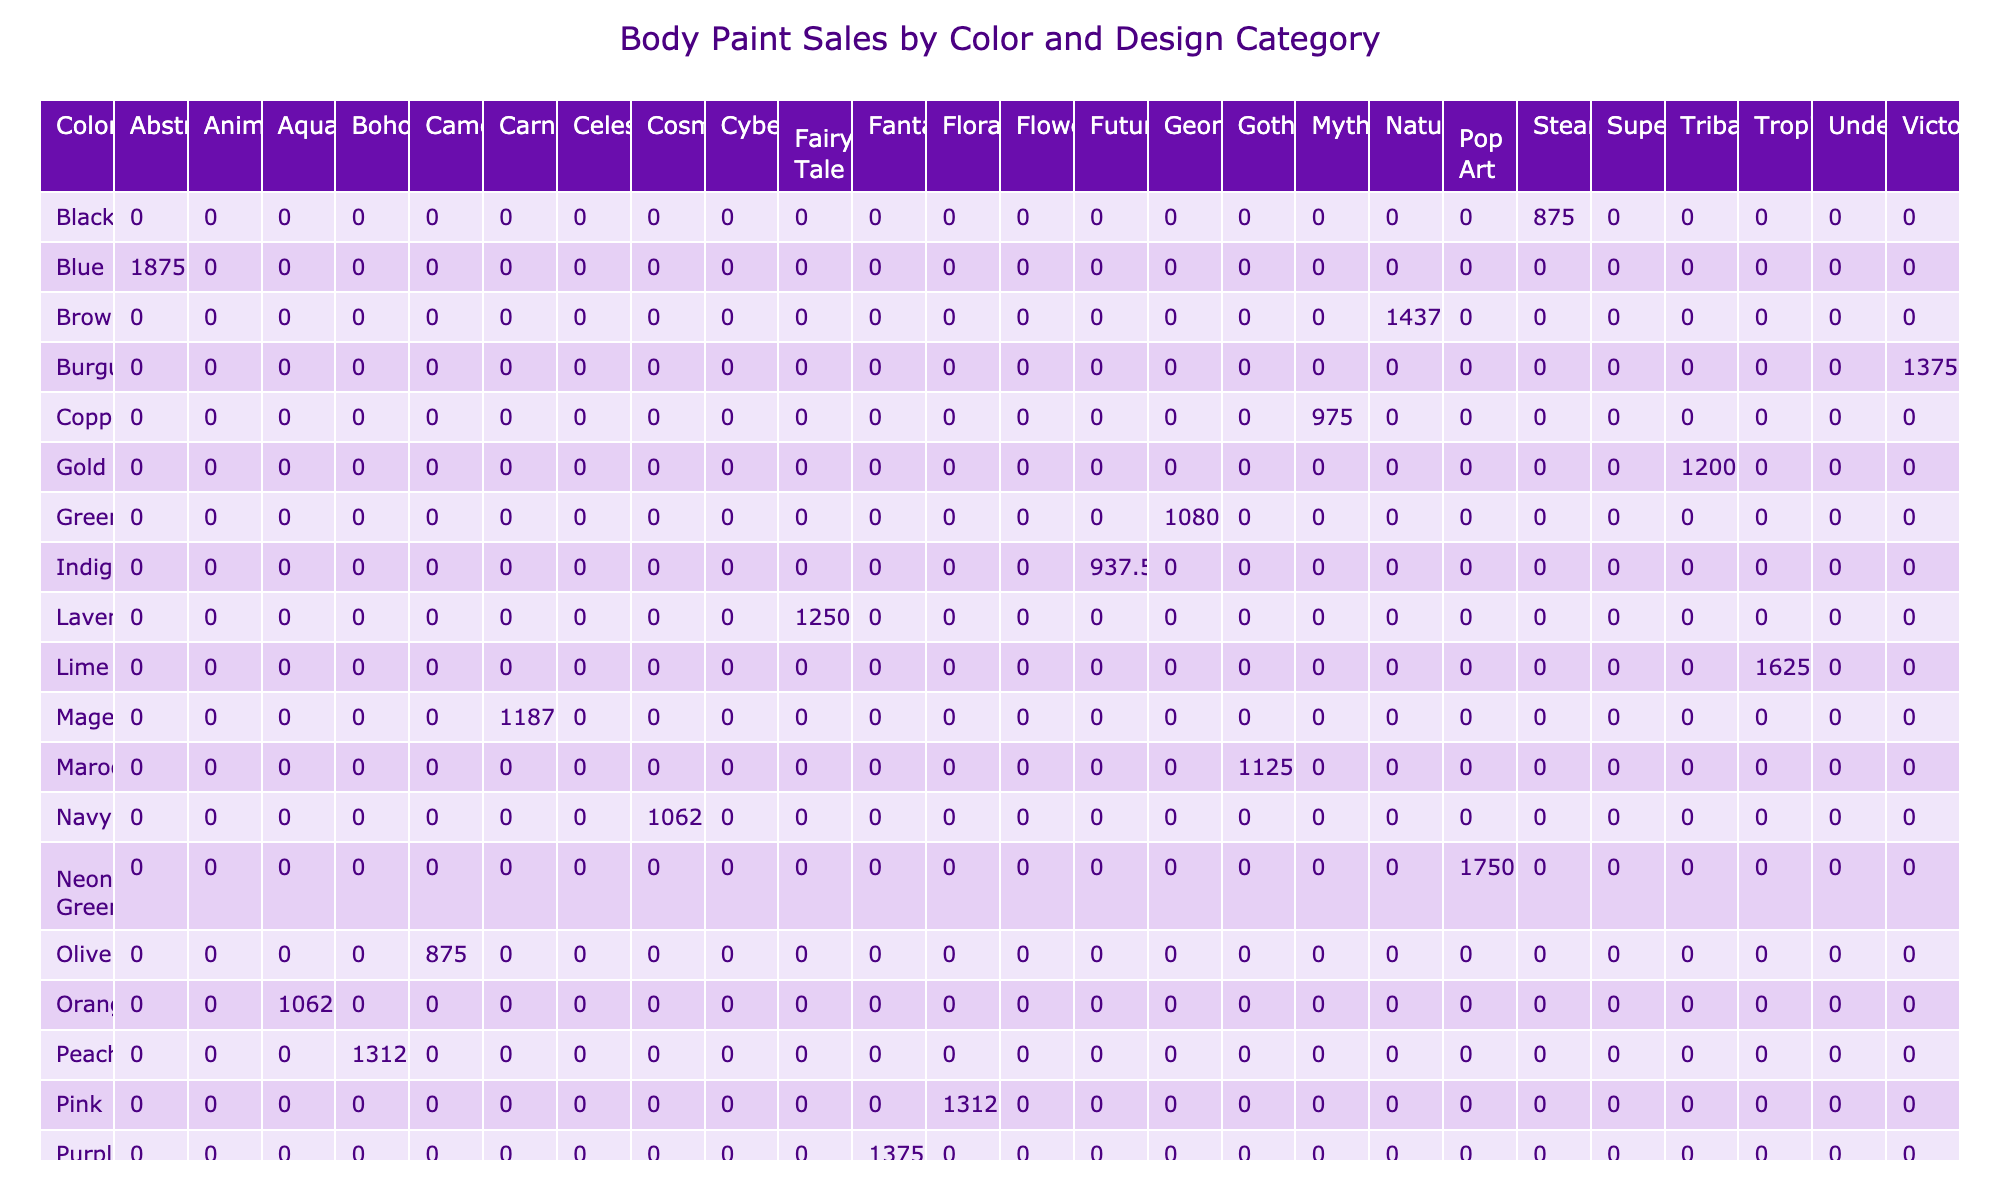What is the total revenue for the color Blue across all design categories? The table shows that the revenue for Blue in the Abstract design category is 1875. Therefore, the total revenue for Blue across all design categories is 1875 since it only appears once in the table.
Answer: 1875 Which color generated the highest revenue in the Tribal design category? In the Tribal design category, the only entry is for the color Gold, with a revenue of 1200. Since it is the only color listed for that category, it must be the highest revenue for Tribal.
Answer: Gold What is the average revenue for the Floral design category? The table shows that the Floral design category has two entries: Pink with revenue 1312.5 and no other entries. Thus, the average is (1312.5) / 1 = 1312.5.
Answer: 1312.5 Is the revenue for the color Black greater than that for the color White? Upon checking the table, the revenue for Black in the Steampunk category is 875, and the revenue for White in the Animals category is 1250. Therefore, 875 is not greater than 1250.
Answer: No Which design category has the highest total revenue from all colors? To find the highest total revenue by design category, we must sum the revenues for each category: Abstract (1875), Flowers (1440), Tribal (1200), Animals (1250), Geometric (1080), Fantasy (1375), Steampunk (875), Celestial (1625), Superheroes (1187.5), Aquatic (1062.5), Floral (1312.5), Cyberpunk (937.5), Nature (1437.5), Mythical (975), Pop Art (1750), Fairy Tale (1250), Underwater (1562.5), Carnival (1187.5), Camouflage (875), Victorian (1375), Cosmic (1062.5), Tropical (1625), Boho (1312.5), Futuristic (937.5), Gothic (1125). The highest total revenue sums to 1750 for Pop Art.
Answer: Pop Art What is the combined revenue for the colors that are categorized under Animals and Nature? The revenue for Animals (White) is 1250, and for Nature (Brown) it is 1437.5. Adding these two gives us: 1250 + 1437.5 = 2687.5.
Answer: 2687.5 